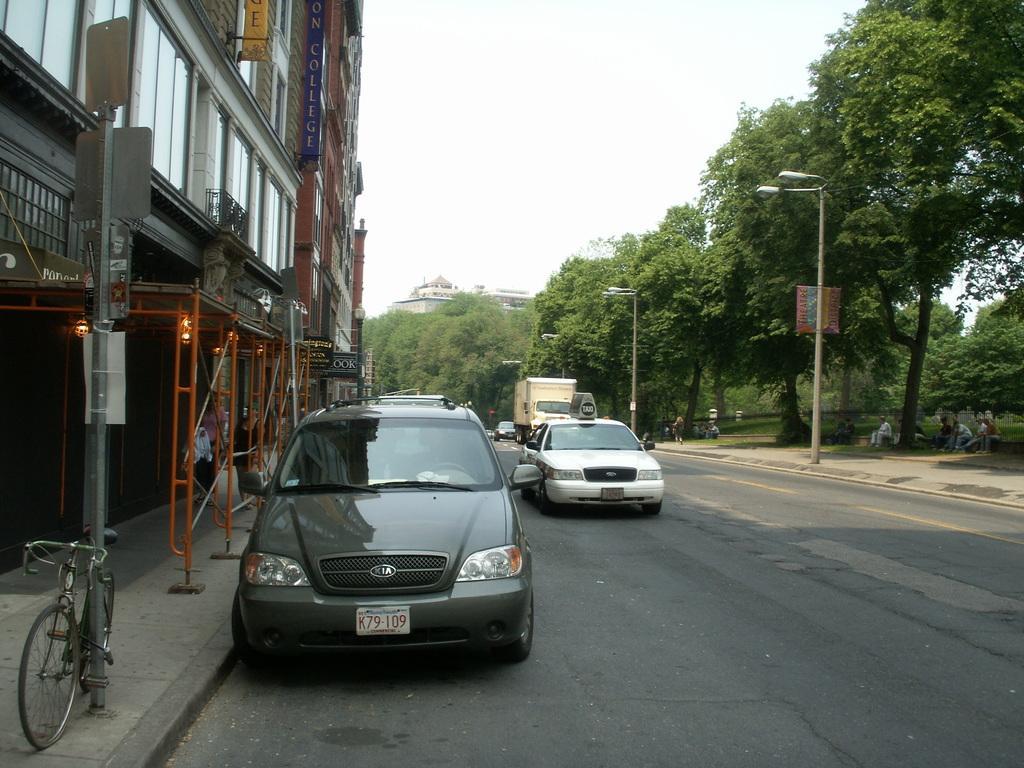Please provide a concise description of this image. As we can see in the image there are buildings, bicycle, cars, truck, street lamps, trees and sky. 